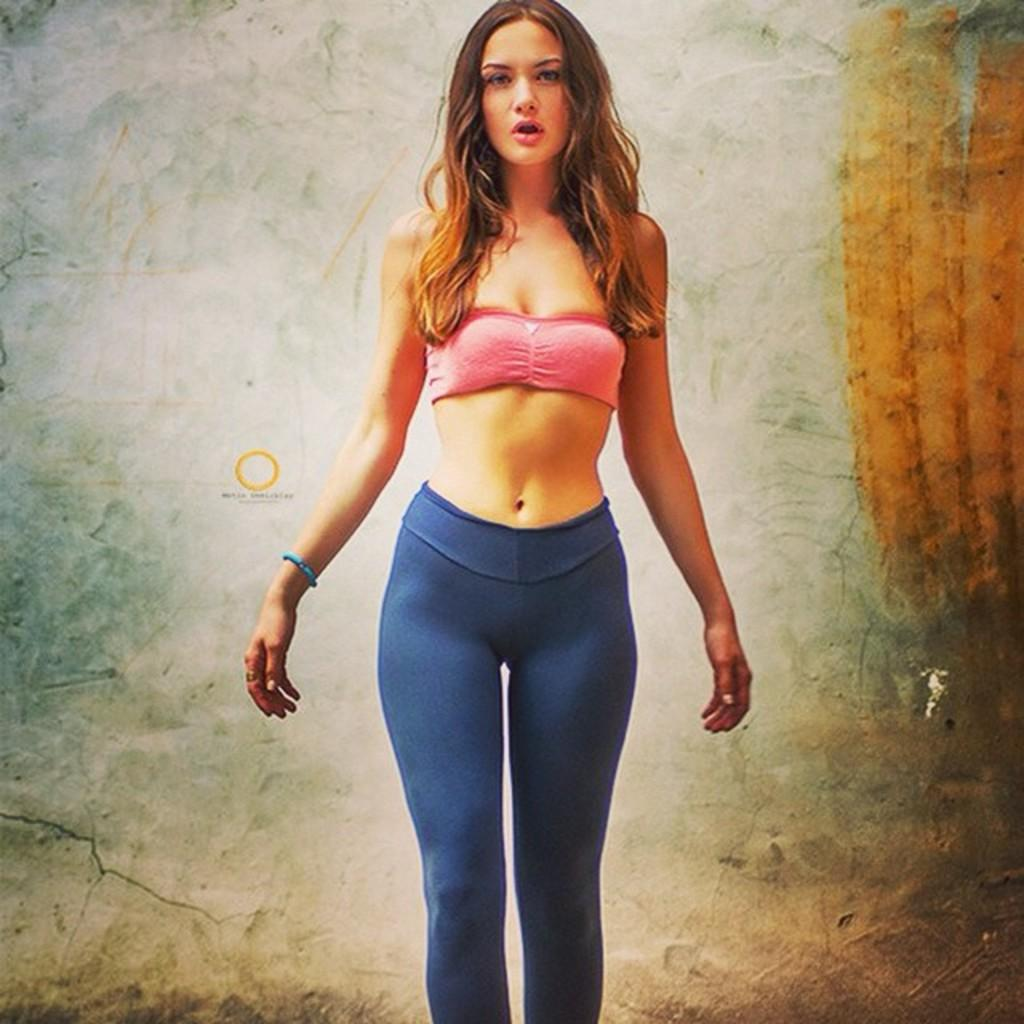What is the main subject of the image? The main subject of the image is a woman. Can you describe the woman's position in the image? The woman is standing in the image. What type of crate is the woman carrying in the image? There is no crate present in the image. What is the price of the gate in the image? There is no gate present in the image. 